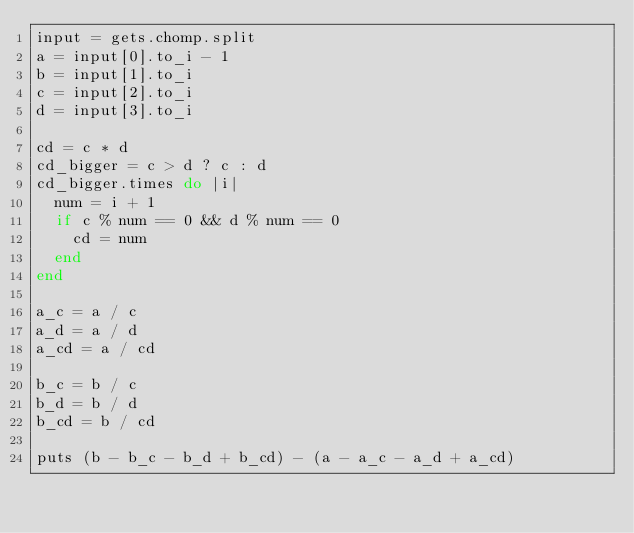Convert code to text. <code><loc_0><loc_0><loc_500><loc_500><_Ruby_>input = gets.chomp.split
a = input[0].to_i - 1
b = input[1].to_i
c = input[2].to_i
d = input[3].to_i

cd = c * d
cd_bigger = c > d ? c : d
cd_bigger.times do |i|
  num = i + 1
  if c % num == 0 && d % num == 0
    cd = num
  end
end

a_c = a / c
a_d = a / d
a_cd = a / cd

b_c = b / c
b_d = b / d
b_cd = b / cd

puts (b - b_c - b_d + b_cd) - (a - a_c - a_d + a_cd)</code> 